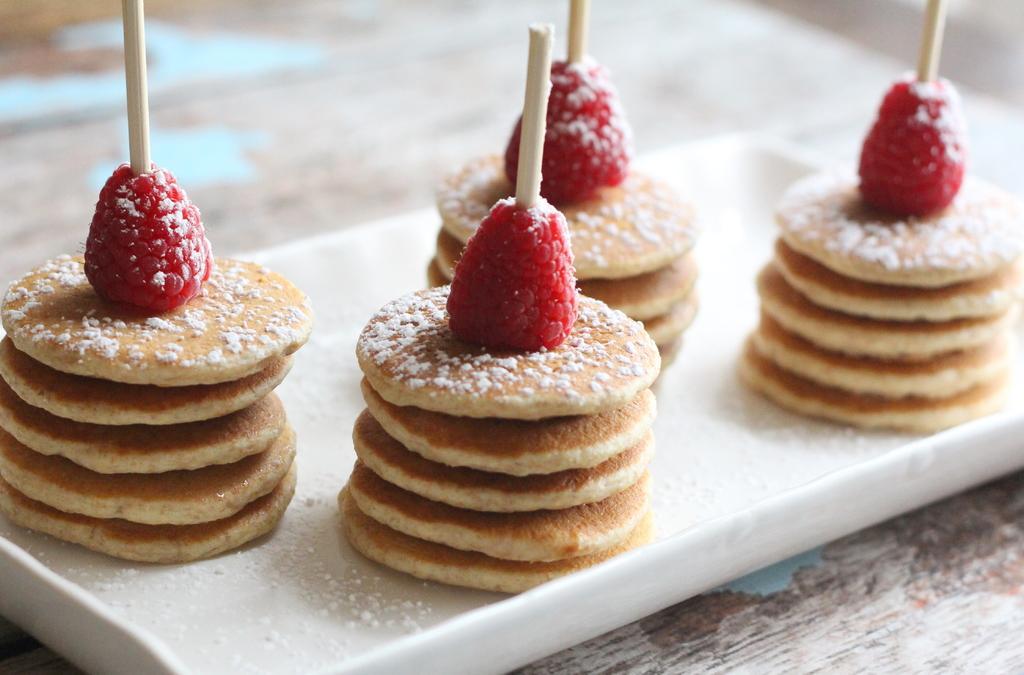Could you give a brief overview of what you see in this image? In this picture we can see there are some food items on a white plate. 